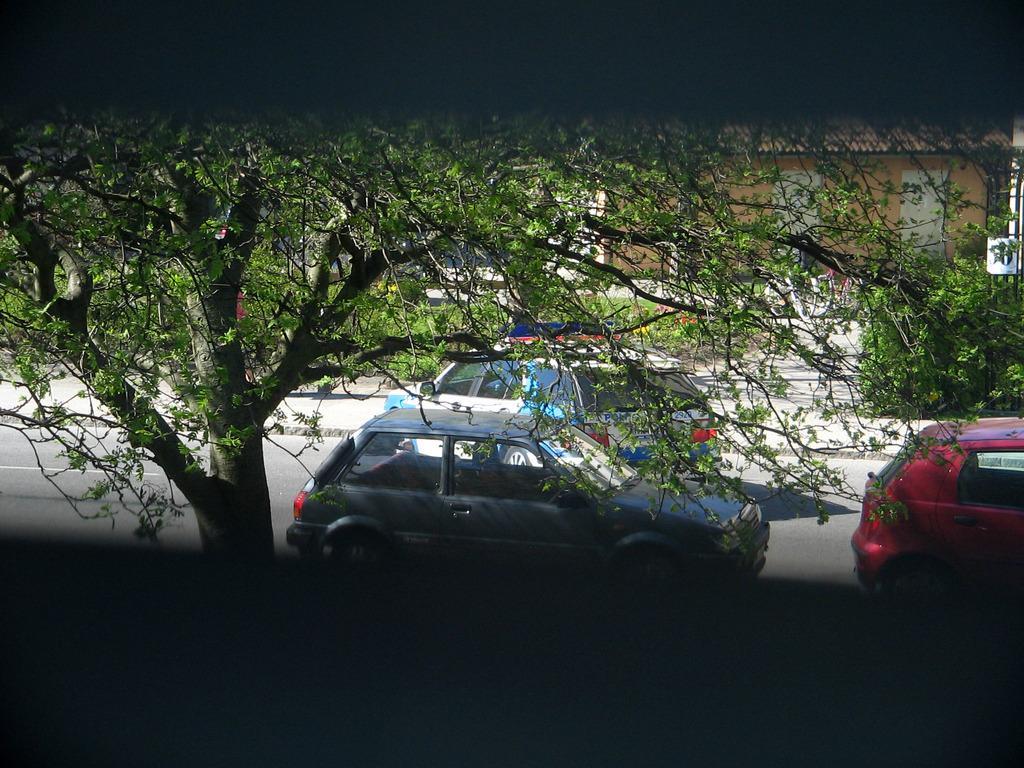In one or two sentences, can you explain what this image depicts? In this image in the front there is a tree and in the center there are cars moving on the road. In the background there are plants and there's grass on the ground and there are buildings. 